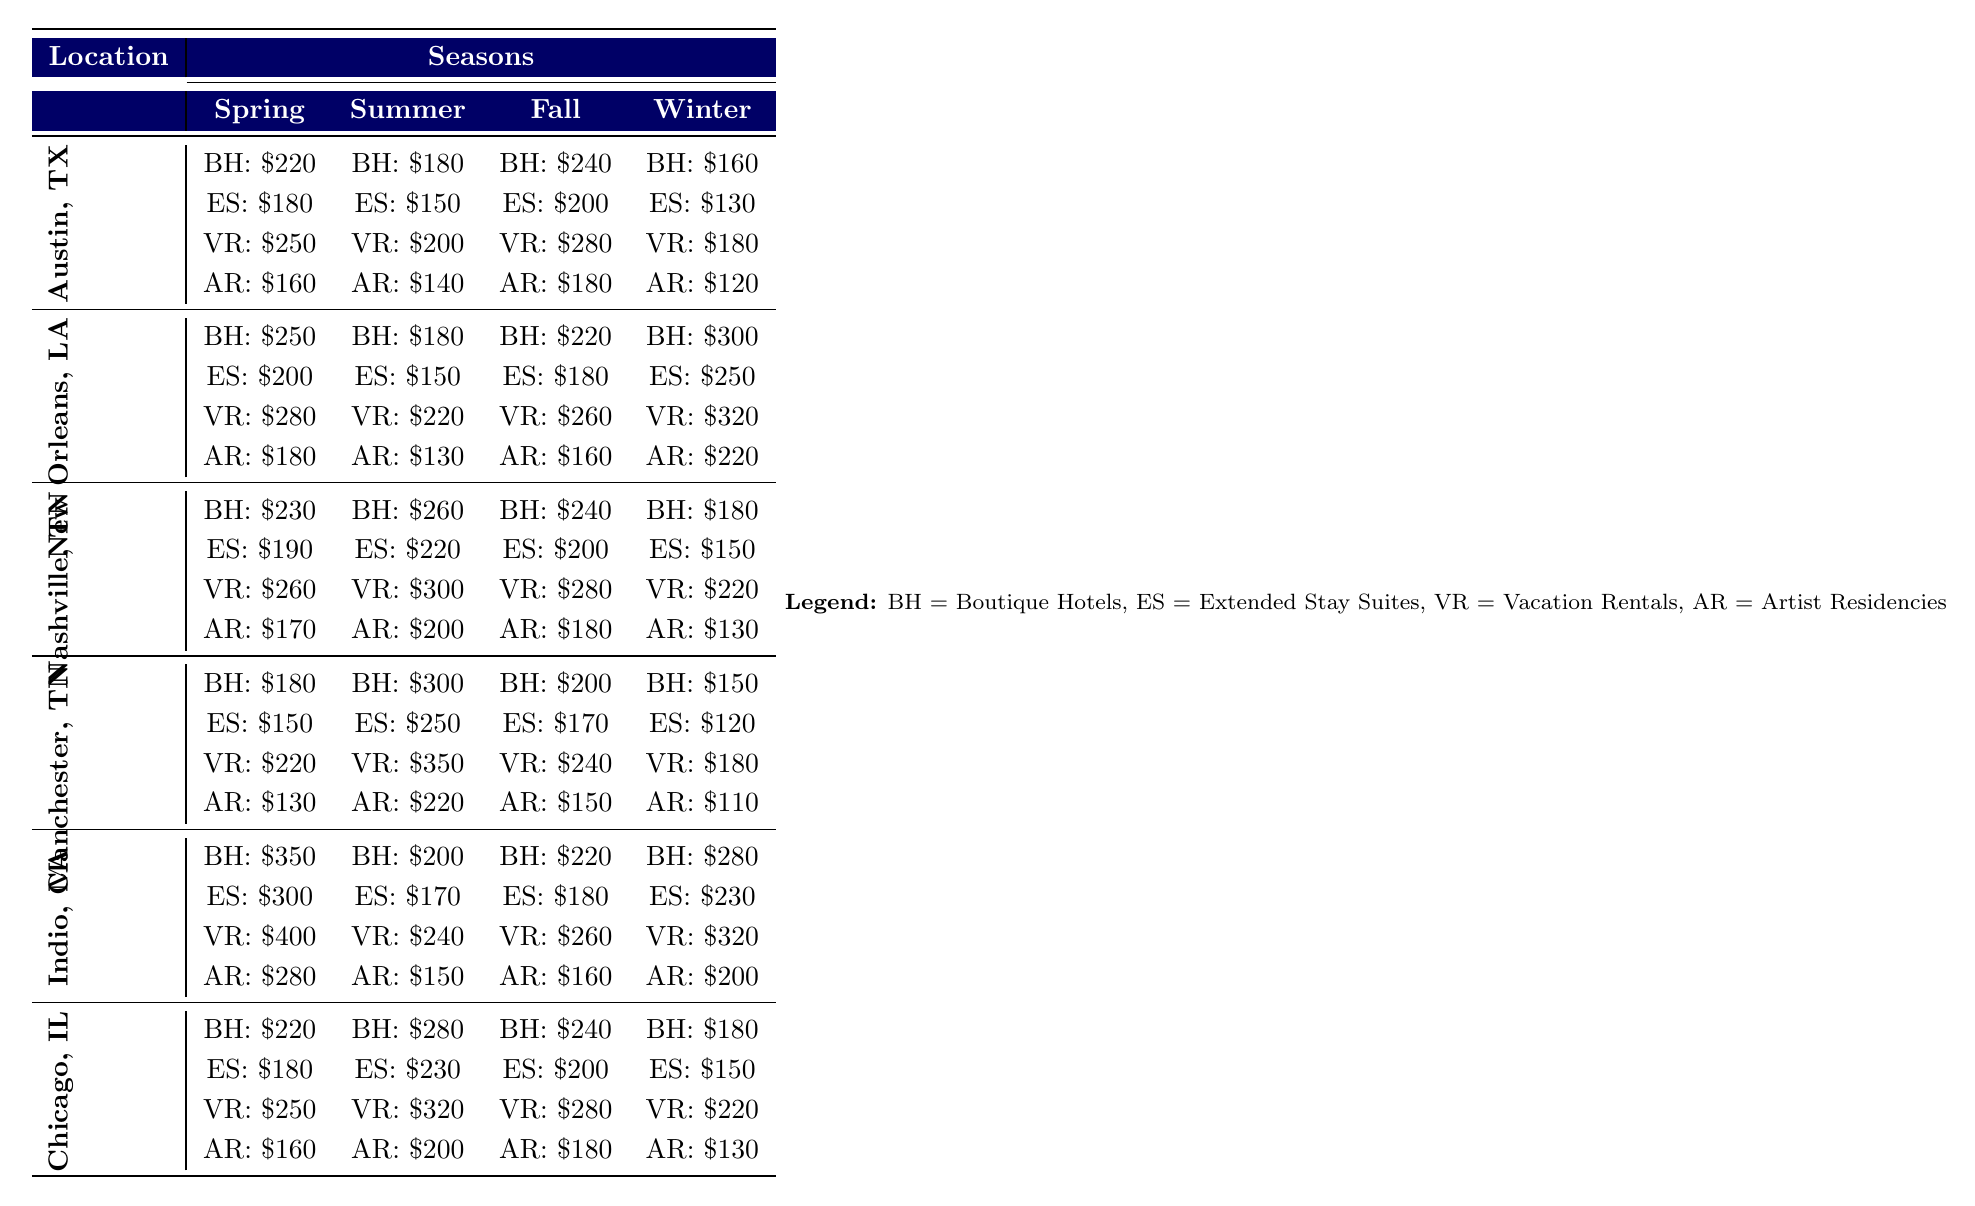What is the price of Boutique Hotels in New Orleans during Winter? According to the table, the price for Boutique Hotels in New Orleans during Winter is listed as $300.
Answer: $300 Which type of accommodation typically has the lowest cost in Austin during Fall? In Austin during Fall, the lowest cost accommodation is Artist Residencies at $180, compared to others like Boutique Hotels at $240, Extended Stay Suites at $200, and Vacation Rentals at $280.
Answer: Artist Residencies What is the average price of Vacation Rentals across all locations in Summer? The prices for Vacation Rentals in Summer across the locations are: Austin ($200), New Orleans ($220), Nashville ($300), Manchester ($350), Indio ($240), and Chicago ($320). Adding these gives $200 + $220 + $300 + $350 + $240 + $320 = $1630. Dividing by 6 gives an average of $1630 / 6 = $271.67.
Answer: $271.67 Is the price of Artist Residencies in Manchester higher in Spring or Winter? In Manchester, the price of Artist Residencies in Spring is $130, while in Winter it is $110. Since $130 is greater than $110, Spring has a higher price for Artist Residencies.
Answer: Yes What is the difference in price between the highest and lowest accommodation types in Indio during Spring? In Indio during Spring, the highest price is for Vacation Rentals at $400, and the lowest is for Artist Residencies at $280. The difference is $400 - $280 = $120.
Answer: $120 In which location do Vacation Rentals have the highest price during the Winter season? The prices for Vacation Rentals during Winter are: Austin ($180), New Orleans ($320), Nashville ($220), Manchester ($180), Indio ($320), and Chicago ($220). The highest price, which is $320, occurs in New Orleans and Indio.
Answer: New Orleans and Indio What is the total cost for Extended Stay Suites in Nashville during Spring and Fall combined? The price for Extended Stay Suites in Nashville during Spring is $190 and in Fall is $200. The total cost is $190 + $200 = $390.
Answer: $390 Is the price of Boutique Hotels in Summer higher than in Winter for Chicago? The price for Boutique Hotels in Chicago during Summer is $280, while in Winter it is $180. Since $280 is greater than $180, the price in Summer is higher.
Answer: Yes Which location has the lowest overall accommodation prices during Winter? Examining the Winter prices: Austin (BH: $160, ES: $130, VR: $180, AR: $120), New Orleans (BH: $300, ES: $250, VR: $320, AR: $220), Nashville (BH: $180, ES: $150, VR: $220, AR: $130), Manchester (BH: $150, ES: $120, VR: $180, AR: $110), Indio (BH: $280, ES: $230, VR: $320, AR: $200), and Chicago (BH: $180, ES: $150, VR: $220, AR: $130). The total lowest overall is in Manchester with a minimum of $110 for Artist Residencies.
Answer: Manchester If a musician chooses to stay in Vacation Rentals in Nashville for both Spring and Winter, how much will they spend in total? The price for Vacation Rentals in Nashville during Spring is $260 and in Winter is $220. The total spent is $260 + $220 = $480.
Answer: $480 